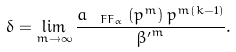Convert formula to latex. <formula><loc_0><loc_0><loc_500><loc_500>\delta = \lim _ { m \to \infty } \frac { a _ { \ F F _ { \alpha } } \left ( p ^ { m } \right ) p ^ { m ( k - 1 ) } } { { \beta ^ { \prime } } ^ { m } } .</formula> 